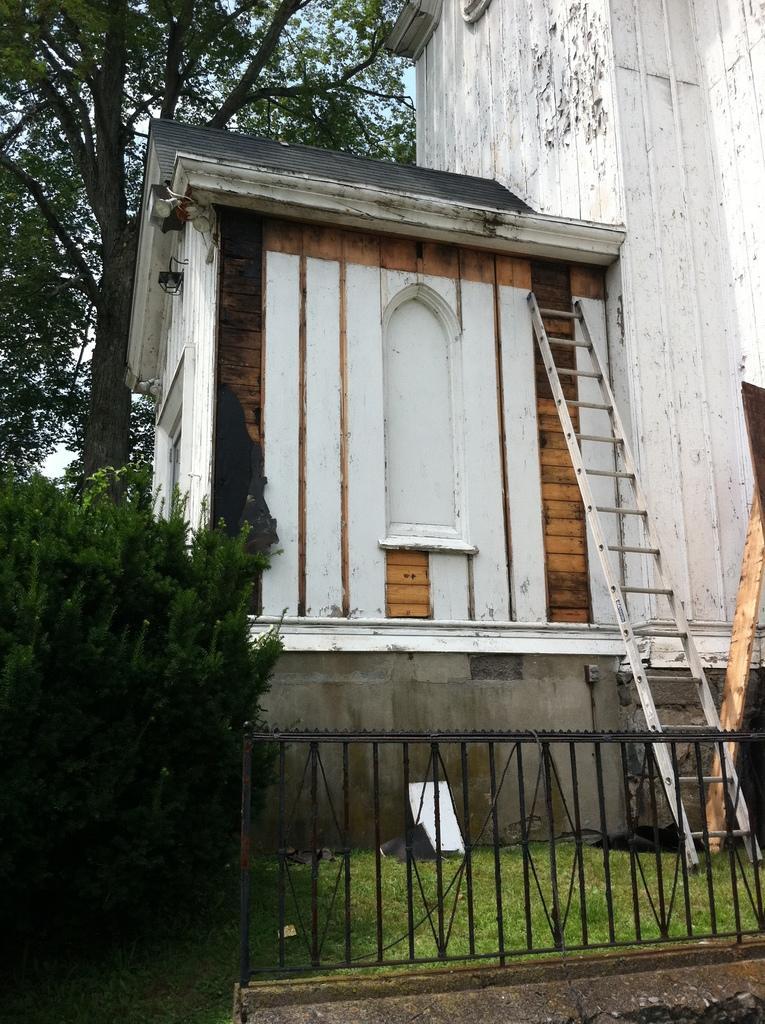Can you describe this image briefly? In this image we can see a building. We can also see a ladder, grass, plants, a tree, a wooden pole and the sky. 